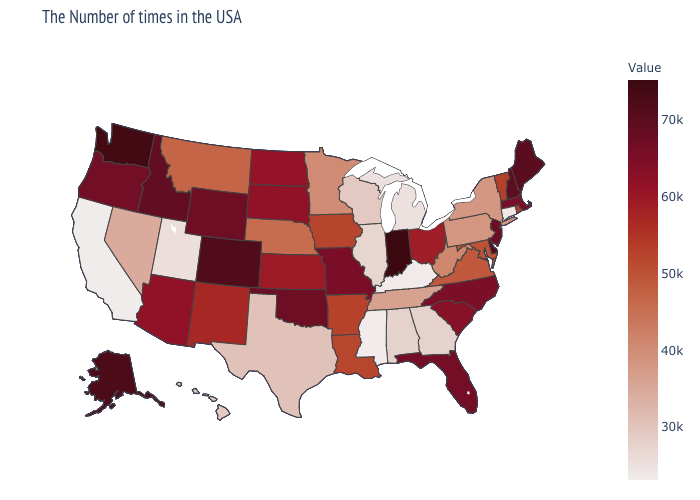Does California have the lowest value in the USA?
Be succinct. Yes. Does Wisconsin have the highest value in the USA?
Write a very short answer. No. Does Iowa have a lower value than Nebraska?
Give a very brief answer. No. Which states have the highest value in the USA?
Answer briefly. Indiana. Does Washington have the highest value in the West?
Be succinct. Yes. Which states hav the highest value in the West?
Write a very short answer. Washington. Which states have the lowest value in the Northeast?
Be succinct. Connecticut. Does Alabama have a higher value than Pennsylvania?
Keep it brief. No. 